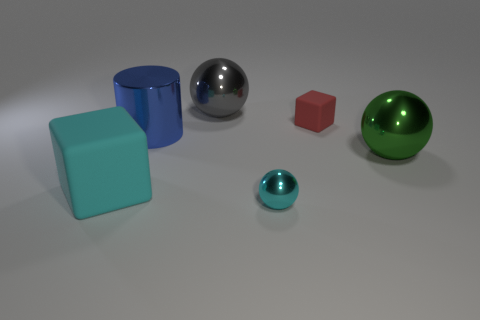Subtract all big shiny balls. How many balls are left? 1 Subtract all cyan blocks. How many blocks are left? 1 Subtract all cylinders. How many objects are left? 5 Add 3 small blue shiny objects. How many objects exist? 9 Subtract all cyan spheres. Subtract all red cubes. How many spheres are left? 2 Subtract 0 yellow blocks. How many objects are left? 6 Subtract all red balls. How many red cubes are left? 1 Subtract all large blue cylinders. Subtract all red rubber cubes. How many objects are left? 4 Add 5 big gray shiny spheres. How many big gray shiny spheres are left? 6 Add 4 large cyan objects. How many large cyan objects exist? 5 